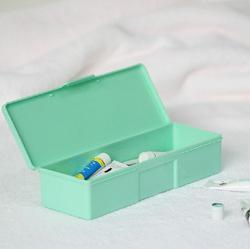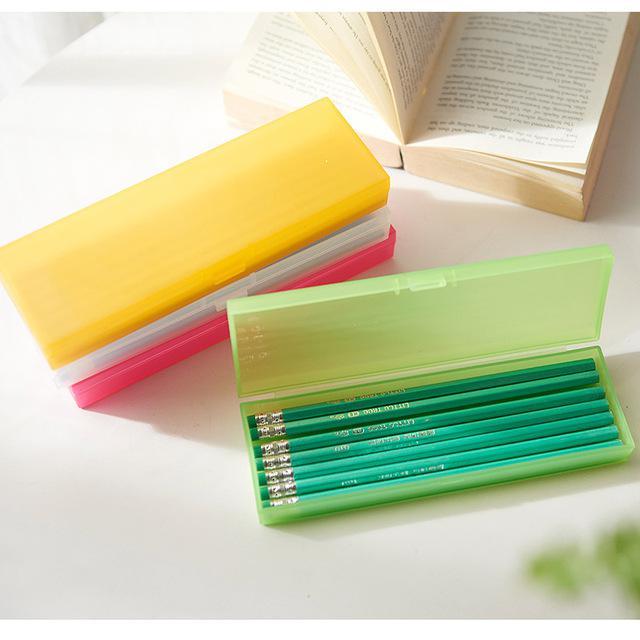The first image is the image on the left, the second image is the image on the right. Considering the images on both sides, is "Each image includes an open plastic rectangular case filled with supplies, and at least one of the open cases pictured is greenish." valid? Answer yes or no. Yes. The first image is the image on the left, the second image is the image on the right. For the images displayed, is the sentence "The pencil cases are open." factually correct? Answer yes or no. Yes. 